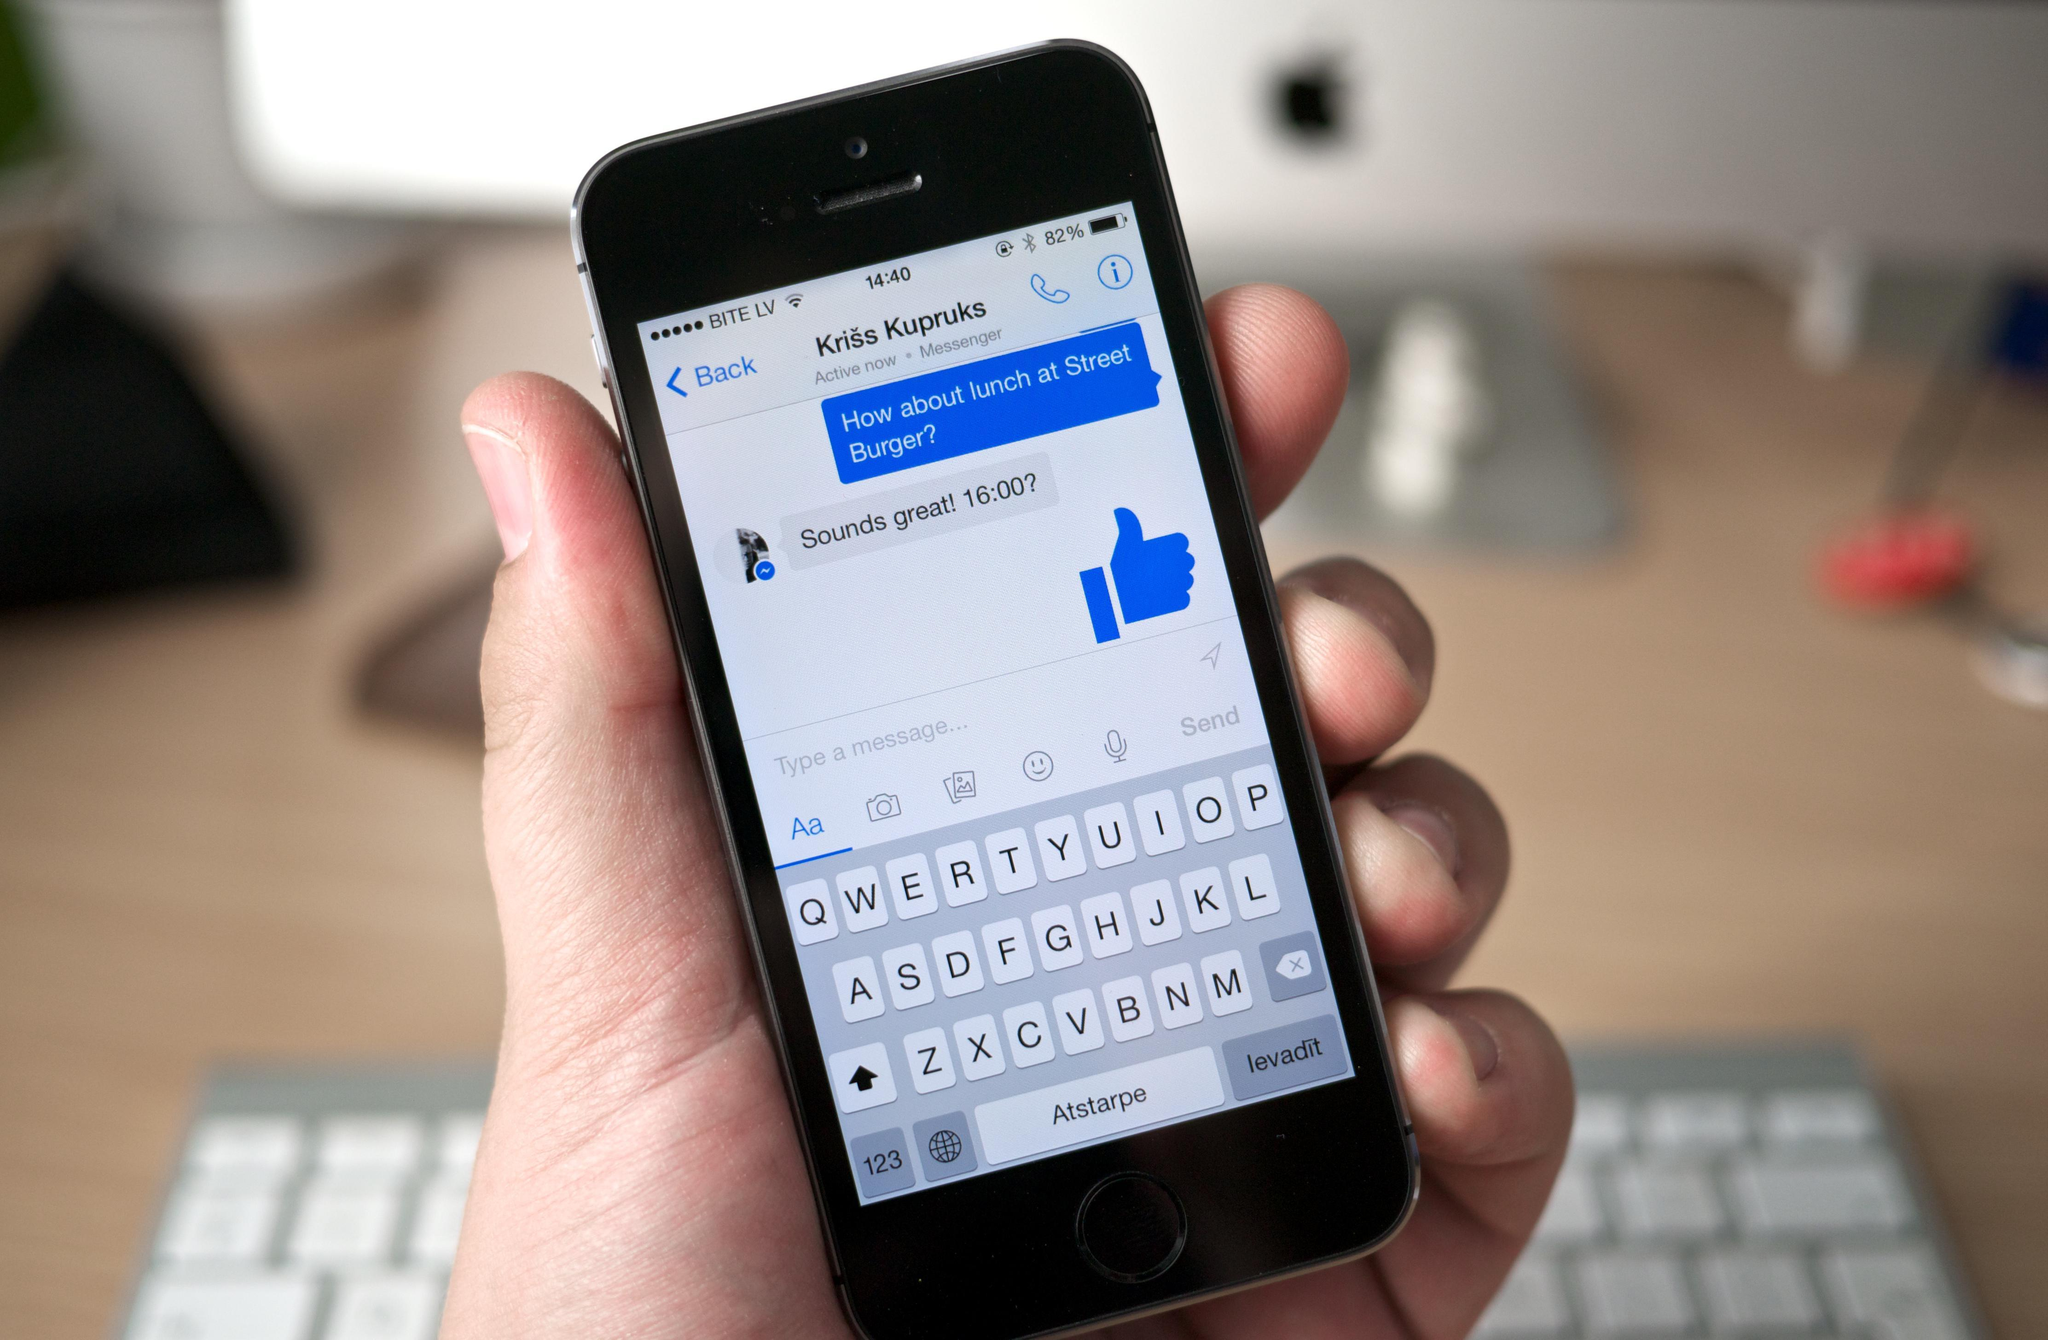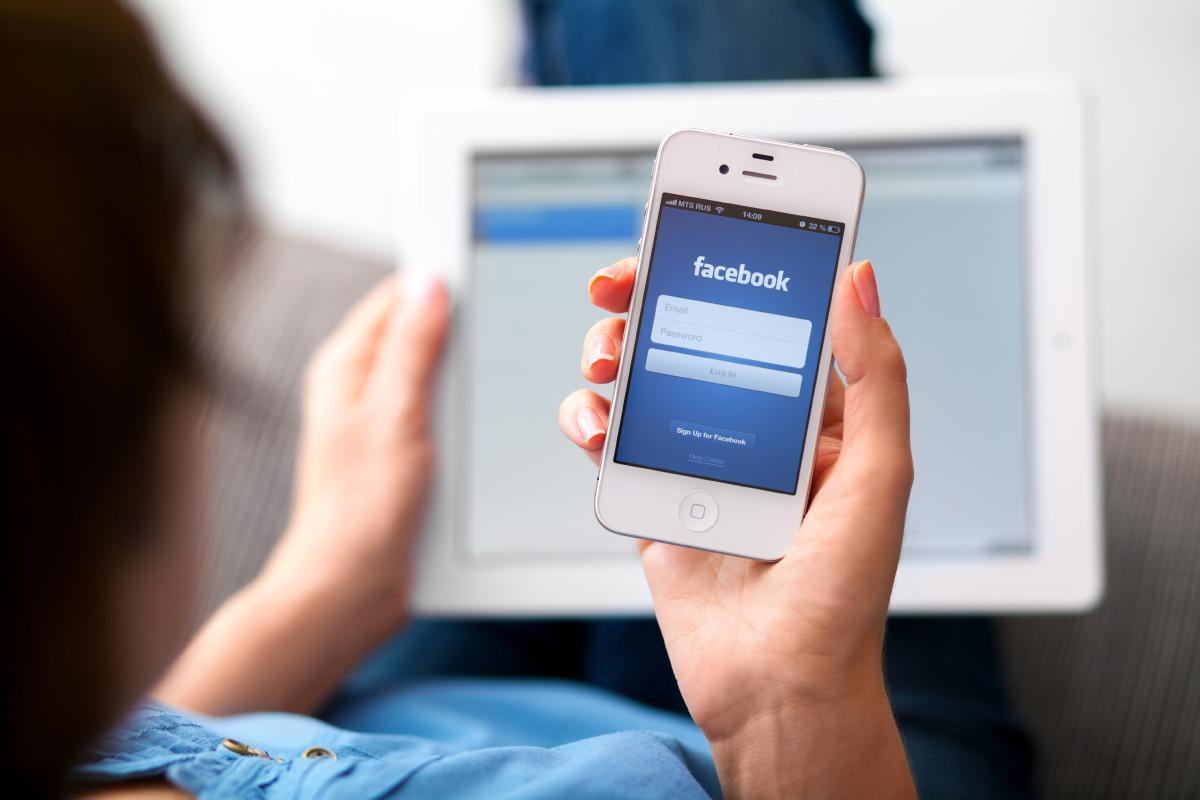The first image is the image on the left, the second image is the image on the right. For the images displayed, is the sentence "The phone in the left image is black and the phone in the right image is white." factually correct? Answer yes or no. Yes. The first image is the image on the left, the second image is the image on the right. Analyze the images presented: Is the assertion "In one of the images, a person is typing on a phone with physical keys." valid? Answer yes or no. No. 